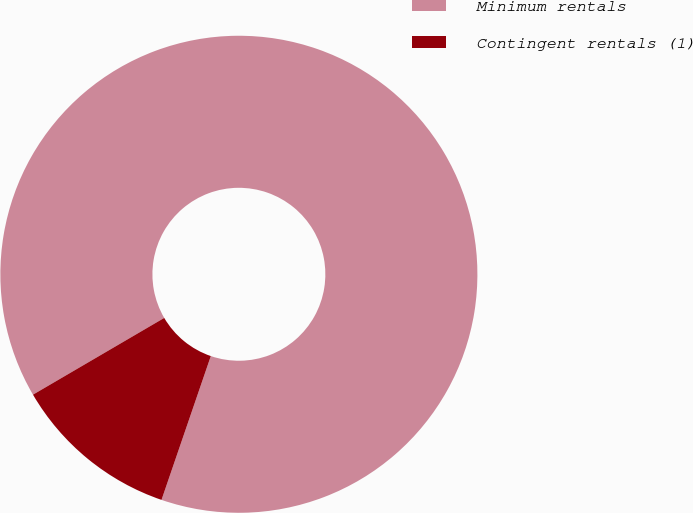Convert chart to OTSL. <chart><loc_0><loc_0><loc_500><loc_500><pie_chart><fcel>Minimum rentals<fcel>Contingent rentals (1)<nl><fcel>88.68%<fcel>11.32%<nl></chart> 